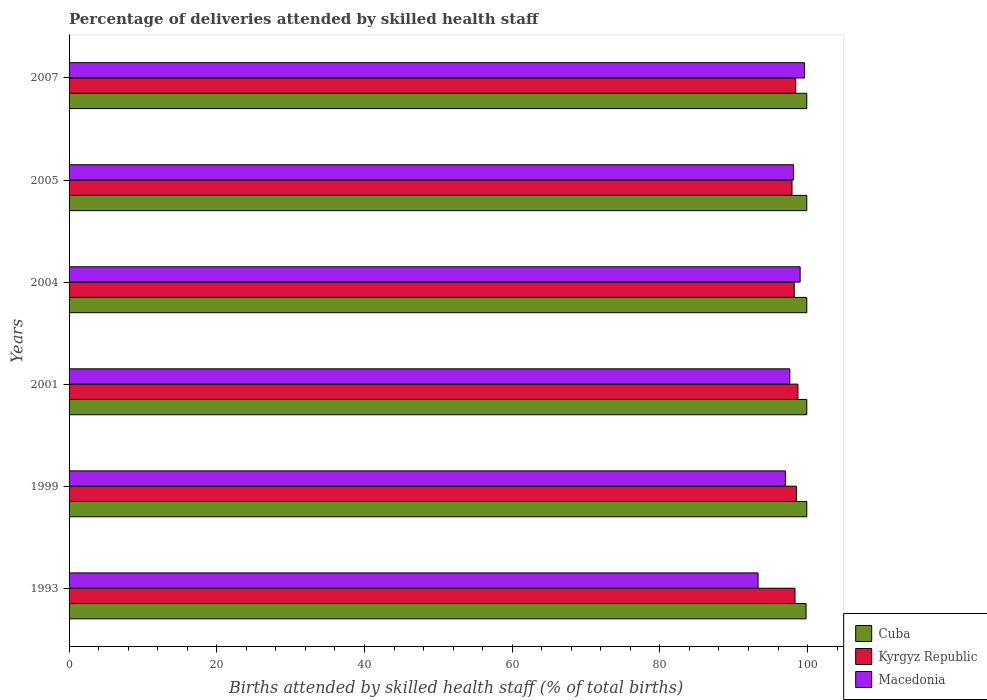How many groups of bars are there?
Your answer should be compact. 6. Are the number of bars per tick equal to the number of legend labels?
Make the answer very short. Yes. How many bars are there on the 5th tick from the top?
Provide a succinct answer. 3. What is the percentage of births attended by skilled health staff in Cuba in 2004?
Provide a short and direct response. 99.9. Across all years, what is the maximum percentage of births attended by skilled health staff in Cuba?
Provide a succinct answer. 99.9. Across all years, what is the minimum percentage of births attended by skilled health staff in Cuba?
Offer a terse response. 99.8. In which year was the percentage of births attended by skilled health staff in Macedonia minimum?
Provide a succinct answer. 1993. What is the total percentage of births attended by skilled health staff in Macedonia in the graph?
Your answer should be compact. 584.6. What is the difference between the percentage of births attended by skilled health staff in Macedonia in 1999 and that in 2005?
Ensure brevity in your answer.  -1.1. What is the difference between the percentage of births attended by skilled health staff in Macedonia in 2005 and the percentage of births attended by skilled health staff in Cuba in 2007?
Make the answer very short. -1.8. What is the average percentage of births attended by skilled health staff in Macedonia per year?
Provide a succinct answer. 97.43. In the year 1999, what is the difference between the percentage of births attended by skilled health staff in Macedonia and percentage of births attended by skilled health staff in Cuba?
Your answer should be compact. -2.9. Is the difference between the percentage of births attended by skilled health staff in Macedonia in 1999 and 2004 greater than the difference between the percentage of births attended by skilled health staff in Cuba in 1999 and 2004?
Keep it short and to the point. No. What is the difference between the highest and the second highest percentage of births attended by skilled health staff in Macedonia?
Provide a short and direct response. 0.6. What is the difference between the highest and the lowest percentage of births attended by skilled health staff in Macedonia?
Your response must be concise. 6.3. What does the 2nd bar from the top in 2001 represents?
Make the answer very short. Kyrgyz Republic. What does the 3rd bar from the bottom in 1993 represents?
Provide a succinct answer. Macedonia. How many bars are there?
Your answer should be compact. 18. How many years are there in the graph?
Keep it short and to the point. 6. What is the difference between two consecutive major ticks on the X-axis?
Provide a short and direct response. 20. Does the graph contain any zero values?
Provide a short and direct response. No. How are the legend labels stacked?
Provide a short and direct response. Vertical. What is the title of the graph?
Offer a terse response. Percentage of deliveries attended by skilled health staff. Does "Trinidad and Tobago" appear as one of the legend labels in the graph?
Give a very brief answer. No. What is the label or title of the X-axis?
Ensure brevity in your answer.  Births attended by skilled health staff (% of total births). What is the label or title of the Y-axis?
Your answer should be very brief. Years. What is the Births attended by skilled health staff (% of total births) of Cuba in 1993?
Keep it short and to the point. 99.8. What is the Births attended by skilled health staff (% of total births) of Kyrgyz Republic in 1993?
Your response must be concise. 98.3. What is the Births attended by skilled health staff (% of total births) of Macedonia in 1993?
Provide a succinct answer. 93.3. What is the Births attended by skilled health staff (% of total births) in Cuba in 1999?
Provide a short and direct response. 99.9. What is the Births attended by skilled health staff (% of total births) of Kyrgyz Republic in 1999?
Offer a very short reply. 98.5. What is the Births attended by skilled health staff (% of total births) in Macedonia in 1999?
Provide a short and direct response. 97. What is the Births attended by skilled health staff (% of total births) in Cuba in 2001?
Keep it short and to the point. 99.9. What is the Births attended by skilled health staff (% of total births) of Kyrgyz Republic in 2001?
Keep it short and to the point. 98.7. What is the Births attended by skilled health staff (% of total births) in Macedonia in 2001?
Your answer should be compact. 97.6. What is the Births attended by skilled health staff (% of total births) of Cuba in 2004?
Ensure brevity in your answer.  99.9. What is the Births attended by skilled health staff (% of total births) of Kyrgyz Republic in 2004?
Provide a succinct answer. 98.2. What is the Births attended by skilled health staff (% of total births) in Macedonia in 2004?
Give a very brief answer. 99. What is the Births attended by skilled health staff (% of total births) in Cuba in 2005?
Make the answer very short. 99.9. What is the Births attended by skilled health staff (% of total births) of Kyrgyz Republic in 2005?
Offer a terse response. 97.9. What is the Births attended by skilled health staff (% of total births) in Macedonia in 2005?
Make the answer very short. 98.1. What is the Births attended by skilled health staff (% of total births) in Cuba in 2007?
Keep it short and to the point. 99.9. What is the Births attended by skilled health staff (% of total births) in Kyrgyz Republic in 2007?
Your answer should be compact. 98.4. What is the Births attended by skilled health staff (% of total births) in Macedonia in 2007?
Keep it short and to the point. 99.6. Across all years, what is the maximum Births attended by skilled health staff (% of total births) in Cuba?
Make the answer very short. 99.9. Across all years, what is the maximum Births attended by skilled health staff (% of total births) of Kyrgyz Republic?
Make the answer very short. 98.7. Across all years, what is the maximum Births attended by skilled health staff (% of total births) in Macedonia?
Provide a succinct answer. 99.6. Across all years, what is the minimum Births attended by skilled health staff (% of total births) of Cuba?
Provide a short and direct response. 99.8. Across all years, what is the minimum Births attended by skilled health staff (% of total births) of Kyrgyz Republic?
Provide a succinct answer. 97.9. Across all years, what is the minimum Births attended by skilled health staff (% of total births) of Macedonia?
Provide a succinct answer. 93.3. What is the total Births attended by skilled health staff (% of total births) in Cuba in the graph?
Your response must be concise. 599.3. What is the total Births attended by skilled health staff (% of total births) of Kyrgyz Republic in the graph?
Make the answer very short. 590. What is the total Births attended by skilled health staff (% of total births) in Macedonia in the graph?
Your response must be concise. 584.6. What is the difference between the Births attended by skilled health staff (% of total births) of Cuba in 1993 and that in 1999?
Offer a terse response. -0.1. What is the difference between the Births attended by skilled health staff (% of total births) in Kyrgyz Republic in 1993 and that in 1999?
Your answer should be very brief. -0.2. What is the difference between the Births attended by skilled health staff (% of total births) of Macedonia in 1993 and that in 2001?
Make the answer very short. -4.3. What is the difference between the Births attended by skilled health staff (% of total births) of Cuba in 1993 and that in 2004?
Give a very brief answer. -0.1. What is the difference between the Births attended by skilled health staff (% of total births) of Cuba in 1993 and that in 2007?
Offer a very short reply. -0.1. What is the difference between the Births attended by skilled health staff (% of total births) in Kyrgyz Republic in 1993 and that in 2007?
Provide a succinct answer. -0.1. What is the difference between the Births attended by skilled health staff (% of total births) of Macedonia in 1993 and that in 2007?
Ensure brevity in your answer.  -6.3. What is the difference between the Births attended by skilled health staff (% of total births) in Cuba in 1999 and that in 2001?
Provide a succinct answer. 0. What is the difference between the Births attended by skilled health staff (% of total births) of Kyrgyz Republic in 1999 and that in 2001?
Your answer should be very brief. -0.2. What is the difference between the Births attended by skilled health staff (% of total births) in Cuba in 1999 and that in 2005?
Ensure brevity in your answer.  0. What is the difference between the Births attended by skilled health staff (% of total births) of Cuba in 1999 and that in 2007?
Make the answer very short. 0. What is the difference between the Births attended by skilled health staff (% of total births) in Kyrgyz Republic in 1999 and that in 2007?
Make the answer very short. 0.1. What is the difference between the Births attended by skilled health staff (% of total births) in Macedonia in 1999 and that in 2007?
Give a very brief answer. -2.6. What is the difference between the Births attended by skilled health staff (% of total births) of Cuba in 2001 and that in 2004?
Offer a very short reply. 0. What is the difference between the Births attended by skilled health staff (% of total births) in Kyrgyz Republic in 2001 and that in 2004?
Offer a very short reply. 0.5. What is the difference between the Births attended by skilled health staff (% of total births) of Cuba in 2001 and that in 2005?
Provide a short and direct response. 0. What is the difference between the Births attended by skilled health staff (% of total births) of Cuba in 2001 and that in 2007?
Offer a terse response. 0. What is the difference between the Births attended by skilled health staff (% of total births) of Kyrgyz Republic in 2001 and that in 2007?
Give a very brief answer. 0.3. What is the difference between the Births attended by skilled health staff (% of total births) in Cuba in 2004 and that in 2005?
Your answer should be very brief. 0. What is the difference between the Births attended by skilled health staff (% of total births) in Macedonia in 2004 and that in 2005?
Keep it short and to the point. 0.9. What is the difference between the Births attended by skilled health staff (% of total births) of Macedonia in 2004 and that in 2007?
Make the answer very short. -0.6. What is the difference between the Births attended by skilled health staff (% of total births) of Kyrgyz Republic in 2005 and that in 2007?
Provide a short and direct response. -0.5. What is the difference between the Births attended by skilled health staff (% of total births) of Macedonia in 2005 and that in 2007?
Provide a short and direct response. -1.5. What is the difference between the Births attended by skilled health staff (% of total births) of Kyrgyz Republic in 1993 and the Births attended by skilled health staff (% of total births) of Macedonia in 1999?
Ensure brevity in your answer.  1.3. What is the difference between the Births attended by skilled health staff (% of total births) in Cuba in 1993 and the Births attended by skilled health staff (% of total births) in Kyrgyz Republic in 2001?
Offer a very short reply. 1.1. What is the difference between the Births attended by skilled health staff (% of total births) of Cuba in 1993 and the Births attended by skilled health staff (% of total births) of Macedonia in 2001?
Ensure brevity in your answer.  2.2. What is the difference between the Births attended by skilled health staff (% of total births) of Cuba in 1993 and the Births attended by skilled health staff (% of total births) of Macedonia in 2004?
Your answer should be very brief. 0.8. What is the difference between the Births attended by skilled health staff (% of total births) of Kyrgyz Republic in 1993 and the Births attended by skilled health staff (% of total births) of Macedonia in 2004?
Your answer should be compact. -0.7. What is the difference between the Births attended by skilled health staff (% of total births) of Cuba in 1993 and the Births attended by skilled health staff (% of total births) of Macedonia in 2005?
Give a very brief answer. 1.7. What is the difference between the Births attended by skilled health staff (% of total births) of Kyrgyz Republic in 1993 and the Births attended by skilled health staff (% of total births) of Macedonia in 2005?
Offer a terse response. 0.2. What is the difference between the Births attended by skilled health staff (% of total births) of Cuba in 1993 and the Births attended by skilled health staff (% of total births) of Macedonia in 2007?
Offer a very short reply. 0.2. What is the difference between the Births attended by skilled health staff (% of total births) of Cuba in 1999 and the Births attended by skilled health staff (% of total births) of Macedonia in 2001?
Your answer should be very brief. 2.3. What is the difference between the Births attended by skilled health staff (% of total births) in Cuba in 1999 and the Births attended by skilled health staff (% of total births) in Kyrgyz Republic in 2004?
Make the answer very short. 1.7. What is the difference between the Births attended by skilled health staff (% of total births) of Kyrgyz Republic in 1999 and the Births attended by skilled health staff (% of total births) of Macedonia in 2004?
Offer a terse response. -0.5. What is the difference between the Births attended by skilled health staff (% of total births) of Cuba in 1999 and the Births attended by skilled health staff (% of total births) of Macedonia in 2005?
Provide a succinct answer. 1.8. What is the difference between the Births attended by skilled health staff (% of total births) of Kyrgyz Republic in 1999 and the Births attended by skilled health staff (% of total births) of Macedonia in 2005?
Provide a succinct answer. 0.4. What is the difference between the Births attended by skilled health staff (% of total births) of Cuba in 2001 and the Births attended by skilled health staff (% of total births) of Kyrgyz Republic in 2004?
Make the answer very short. 1.7. What is the difference between the Births attended by skilled health staff (% of total births) of Cuba in 2001 and the Births attended by skilled health staff (% of total births) of Kyrgyz Republic in 2005?
Offer a terse response. 2. What is the difference between the Births attended by skilled health staff (% of total births) of Kyrgyz Republic in 2001 and the Births attended by skilled health staff (% of total births) of Macedonia in 2005?
Your response must be concise. 0.6. What is the difference between the Births attended by skilled health staff (% of total births) in Cuba in 2001 and the Births attended by skilled health staff (% of total births) in Kyrgyz Republic in 2007?
Offer a terse response. 1.5. What is the difference between the Births attended by skilled health staff (% of total births) in Cuba in 2001 and the Births attended by skilled health staff (% of total births) in Macedonia in 2007?
Make the answer very short. 0.3. What is the difference between the Births attended by skilled health staff (% of total births) of Kyrgyz Republic in 2001 and the Births attended by skilled health staff (% of total births) of Macedonia in 2007?
Keep it short and to the point. -0.9. What is the difference between the Births attended by skilled health staff (% of total births) of Cuba in 2004 and the Births attended by skilled health staff (% of total births) of Kyrgyz Republic in 2005?
Keep it short and to the point. 2. What is the difference between the Births attended by skilled health staff (% of total births) in Kyrgyz Republic in 2004 and the Births attended by skilled health staff (% of total births) in Macedonia in 2005?
Make the answer very short. 0.1. What is the difference between the Births attended by skilled health staff (% of total births) of Cuba in 2004 and the Births attended by skilled health staff (% of total births) of Kyrgyz Republic in 2007?
Ensure brevity in your answer.  1.5. What is the difference between the Births attended by skilled health staff (% of total births) in Kyrgyz Republic in 2004 and the Births attended by skilled health staff (% of total births) in Macedonia in 2007?
Offer a very short reply. -1.4. What is the difference between the Births attended by skilled health staff (% of total births) in Kyrgyz Republic in 2005 and the Births attended by skilled health staff (% of total births) in Macedonia in 2007?
Make the answer very short. -1.7. What is the average Births attended by skilled health staff (% of total births) in Cuba per year?
Your answer should be compact. 99.88. What is the average Births attended by skilled health staff (% of total births) in Kyrgyz Republic per year?
Provide a succinct answer. 98.33. What is the average Births attended by skilled health staff (% of total births) in Macedonia per year?
Your answer should be very brief. 97.43. In the year 1993, what is the difference between the Births attended by skilled health staff (% of total births) of Cuba and Births attended by skilled health staff (% of total births) of Macedonia?
Your answer should be very brief. 6.5. In the year 1999, what is the difference between the Births attended by skilled health staff (% of total births) of Cuba and Births attended by skilled health staff (% of total births) of Kyrgyz Republic?
Your response must be concise. 1.4. In the year 1999, what is the difference between the Births attended by skilled health staff (% of total births) of Cuba and Births attended by skilled health staff (% of total births) of Macedonia?
Make the answer very short. 2.9. In the year 1999, what is the difference between the Births attended by skilled health staff (% of total births) in Kyrgyz Republic and Births attended by skilled health staff (% of total births) in Macedonia?
Keep it short and to the point. 1.5. In the year 2001, what is the difference between the Births attended by skilled health staff (% of total births) in Cuba and Births attended by skilled health staff (% of total births) in Kyrgyz Republic?
Keep it short and to the point. 1.2. In the year 2001, what is the difference between the Births attended by skilled health staff (% of total births) of Kyrgyz Republic and Births attended by skilled health staff (% of total births) of Macedonia?
Offer a terse response. 1.1. In the year 2004, what is the difference between the Births attended by skilled health staff (% of total births) of Kyrgyz Republic and Births attended by skilled health staff (% of total births) of Macedonia?
Keep it short and to the point. -0.8. In the year 2007, what is the difference between the Births attended by skilled health staff (% of total births) in Kyrgyz Republic and Births attended by skilled health staff (% of total births) in Macedonia?
Offer a terse response. -1.2. What is the ratio of the Births attended by skilled health staff (% of total births) of Macedonia in 1993 to that in 1999?
Ensure brevity in your answer.  0.96. What is the ratio of the Births attended by skilled health staff (% of total births) in Cuba in 1993 to that in 2001?
Your response must be concise. 1. What is the ratio of the Births attended by skilled health staff (% of total births) of Kyrgyz Republic in 1993 to that in 2001?
Your answer should be very brief. 1. What is the ratio of the Births attended by skilled health staff (% of total births) of Macedonia in 1993 to that in 2001?
Offer a very short reply. 0.96. What is the ratio of the Births attended by skilled health staff (% of total births) of Macedonia in 1993 to that in 2004?
Provide a succinct answer. 0.94. What is the ratio of the Births attended by skilled health staff (% of total births) of Cuba in 1993 to that in 2005?
Your response must be concise. 1. What is the ratio of the Births attended by skilled health staff (% of total births) of Kyrgyz Republic in 1993 to that in 2005?
Give a very brief answer. 1. What is the ratio of the Births attended by skilled health staff (% of total births) in Macedonia in 1993 to that in 2005?
Make the answer very short. 0.95. What is the ratio of the Births attended by skilled health staff (% of total births) of Macedonia in 1993 to that in 2007?
Make the answer very short. 0.94. What is the ratio of the Births attended by skilled health staff (% of total births) of Kyrgyz Republic in 1999 to that in 2001?
Your answer should be very brief. 1. What is the ratio of the Births attended by skilled health staff (% of total births) of Macedonia in 1999 to that in 2001?
Provide a succinct answer. 0.99. What is the ratio of the Births attended by skilled health staff (% of total births) in Cuba in 1999 to that in 2004?
Your answer should be compact. 1. What is the ratio of the Births attended by skilled health staff (% of total births) of Kyrgyz Republic in 1999 to that in 2004?
Give a very brief answer. 1. What is the ratio of the Births attended by skilled health staff (% of total births) of Macedonia in 1999 to that in 2004?
Your response must be concise. 0.98. What is the ratio of the Births attended by skilled health staff (% of total births) in Kyrgyz Republic in 1999 to that in 2005?
Your response must be concise. 1.01. What is the ratio of the Births attended by skilled health staff (% of total births) in Macedonia in 1999 to that in 2007?
Your answer should be compact. 0.97. What is the ratio of the Births attended by skilled health staff (% of total births) of Macedonia in 2001 to that in 2004?
Offer a very short reply. 0.99. What is the ratio of the Births attended by skilled health staff (% of total births) of Kyrgyz Republic in 2001 to that in 2005?
Your answer should be compact. 1.01. What is the ratio of the Births attended by skilled health staff (% of total births) in Kyrgyz Republic in 2001 to that in 2007?
Your answer should be compact. 1. What is the ratio of the Births attended by skilled health staff (% of total births) in Macedonia in 2001 to that in 2007?
Give a very brief answer. 0.98. What is the ratio of the Births attended by skilled health staff (% of total births) of Macedonia in 2004 to that in 2005?
Your response must be concise. 1.01. What is the ratio of the Births attended by skilled health staff (% of total births) in Kyrgyz Republic in 2004 to that in 2007?
Offer a terse response. 1. What is the ratio of the Births attended by skilled health staff (% of total births) of Cuba in 2005 to that in 2007?
Provide a short and direct response. 1. What is the ratio of the Births attended by skilled health staff (% of total births) in Macedonia in 2005 to that in 2007?
Provide a short and direct response. 0.98. What is the difference between the highest and the second highest Births attended by skilled health staff (% of total births) of Cuba?
Your answer should be compact. 0. What is the difference between the highest and the second highest Births attended by skilled health staff (% of total births) of Kyrgyz Republic?
Offer a terse response. 0.2. What is the difference between the highest and the lowest Births attended by skilled health staff (% of total births) in Kyrgyz Republic?
Your answer should be compact. 0.8. 